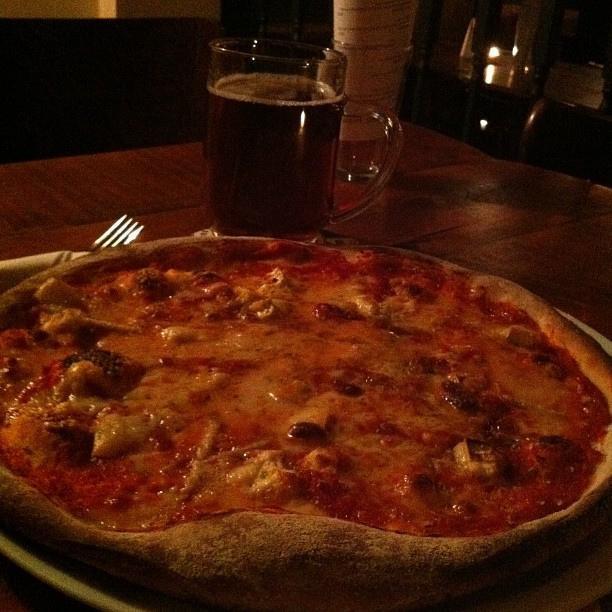How many orange slices can you see?
Give a very brief answer. 0. 